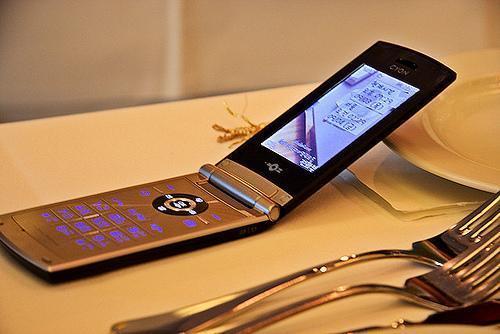How many electronic devices are there?
Give a very brief answer. 1. How many electronics are in this photo?
Give a very brief answer. 1. How many dining tables are in the picture?
Give a very brief answer. 2. How many forks are in the picture?
Give a very brief answer. 2. 